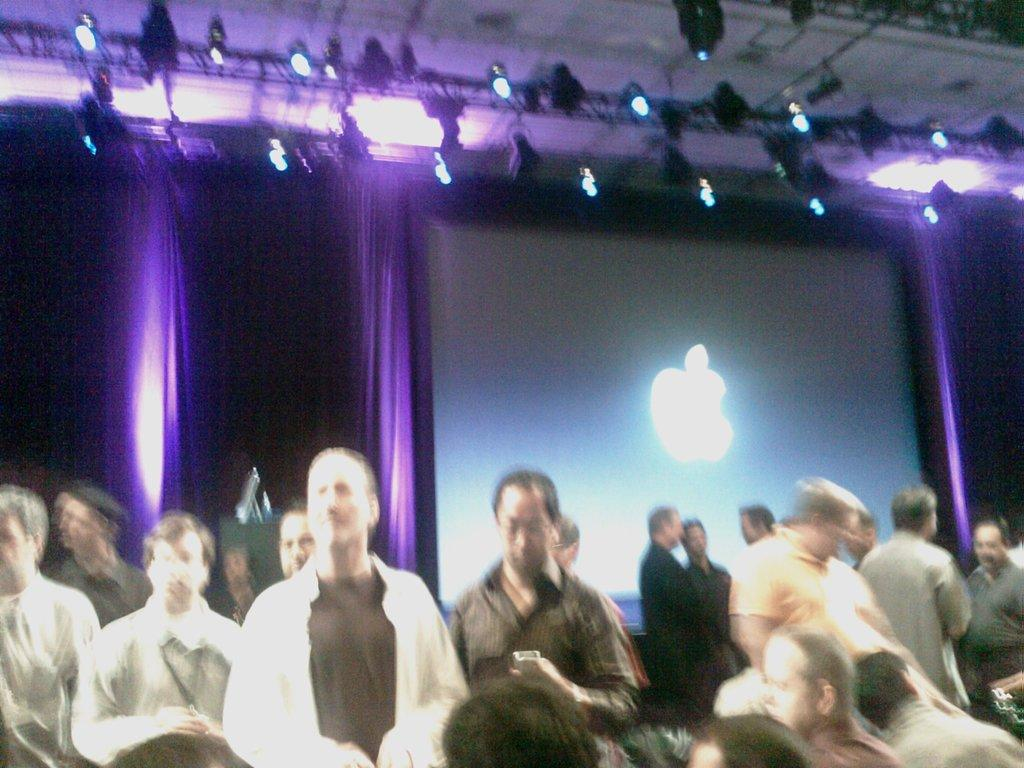What are the people in the image doing? The people in the image are sitting and standing. What can be seen in the background of the image? There is a screen and curtains in the background of the image. What is visible at the top of the image? The ceiling is visible at the top of the image. What type of lighting is present in the image? There are focus lights in the image. Is there any quicksand present in the image? No, there is no quicksand present in the image. What type of observation can be made about the people's interests in the image? The image does not provide any information about the people's interests, so it cannot be determined from the image. 